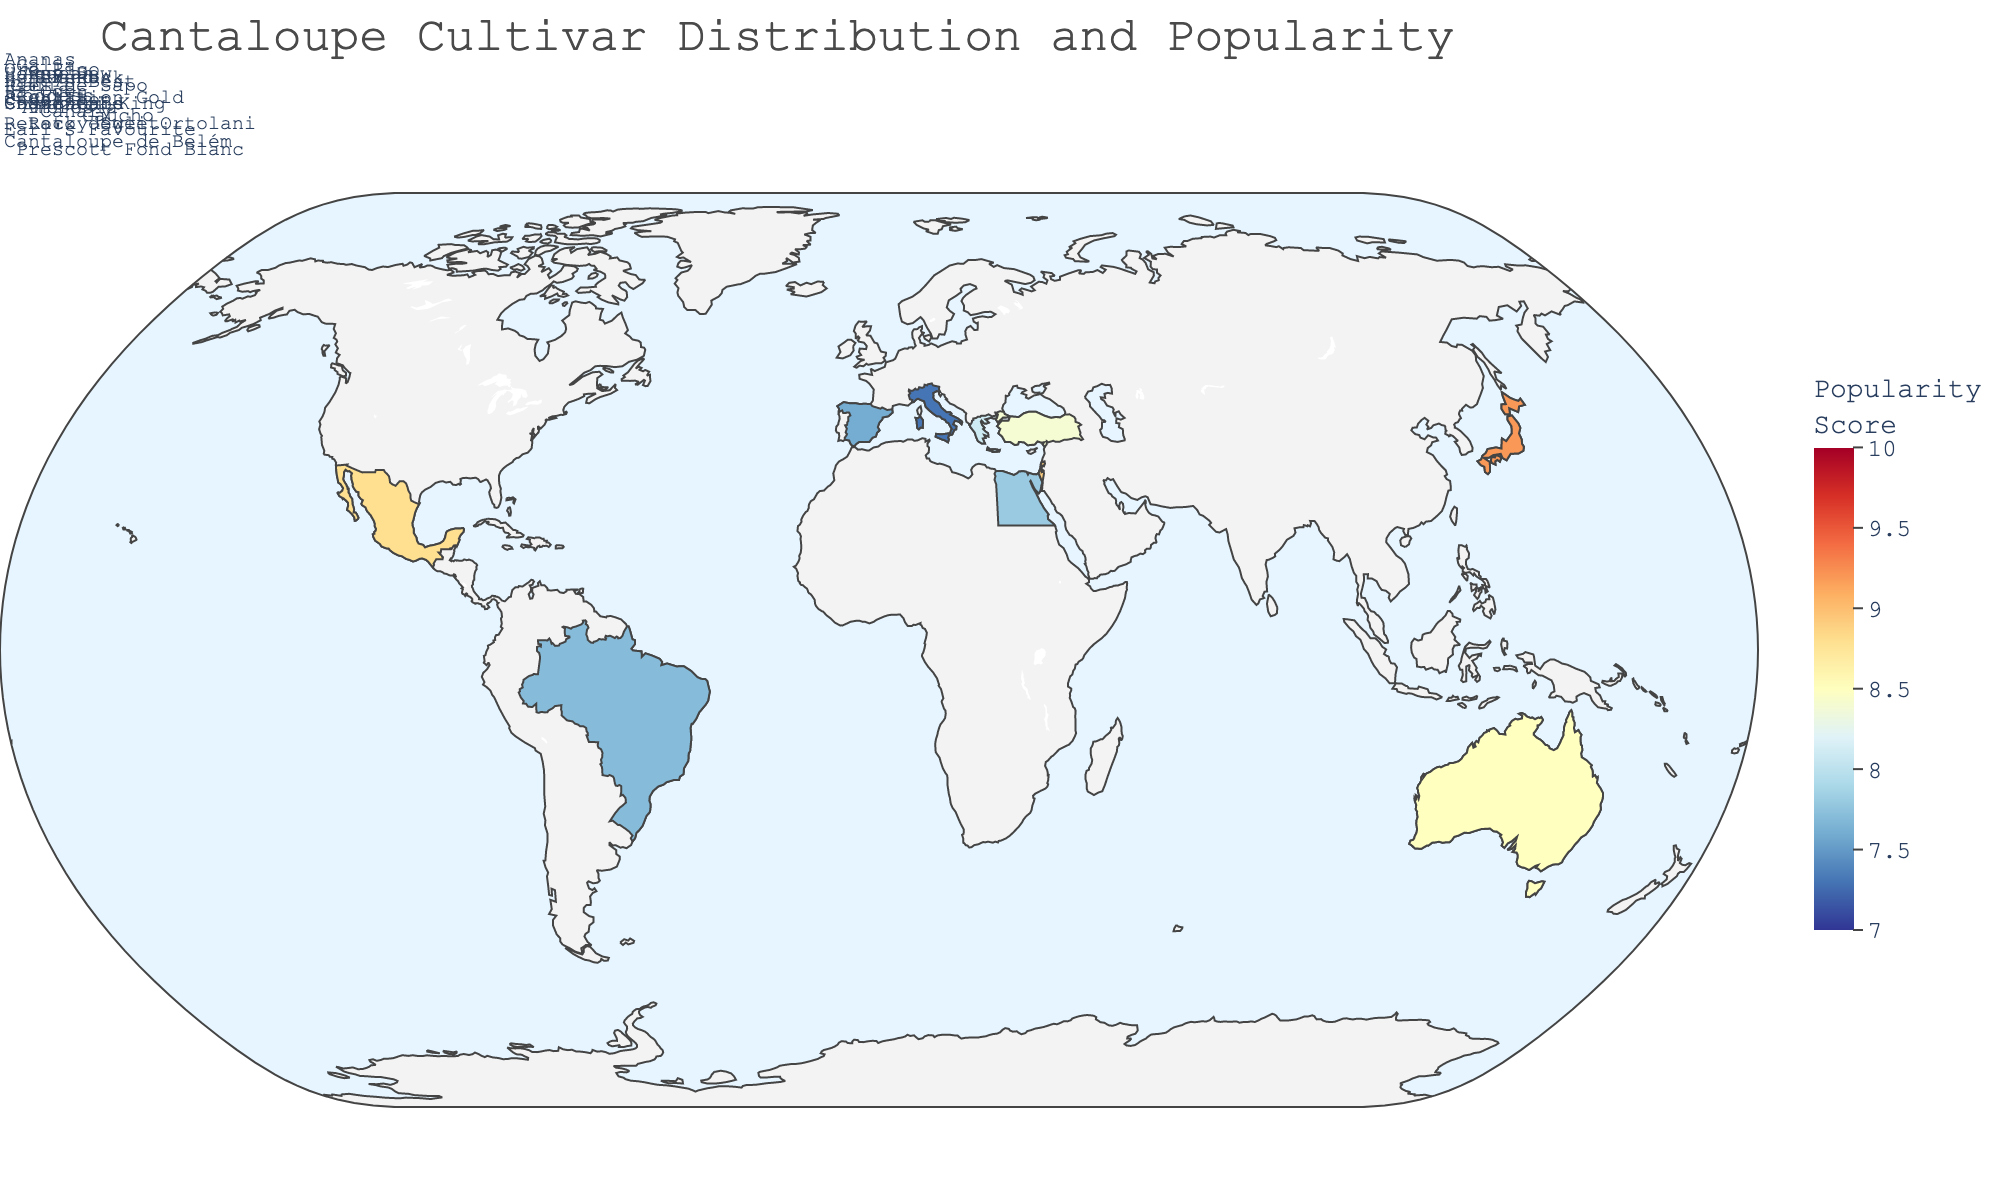how many regions are represented on the map? Looking at the geographic plot, count the number of distinct regions listed. There are 14 regions depicted.
Answer: 14 Which region has the highest Popularity Score? Identify the region with the highest numerical Popularity Score on the map. California has the highest Popularity Score of 9.5.
Answer: California What is the range of the Popularity Scores among all regions? Find the minimum and maximum Popularity Scores and calculate the difference between them. The minimum score is 7.3 (Italy) and the maximum is 9.5 (California), so the range is 9.5 - 7.3 = 2.2.
Answer: 2.2 Which regions have a Secondary Cultivar of 'Galia'? Look at the annotations or hover-over data on the map to find regions with 'Galia' listed as the secondary cultivar. Regions with 'Galia' as the secondary cultivar are Mexico and Turkey.
Answer: Mexico, Turkey What are the Dominant and Secondary Cultivars in Israel? Locate Israel on the map and check the annotations or hover-over data to find the listed cultivars. The Dominant Cultivar is 'Galia' and the Secondary Cultivar is 'Ha'Ogen'.
Answer: Galia, Ha'Ogen How does the Popularity Score of Japan compare to that of Israel? Compare the Popularity Scores next to the regions Japan and Israel. Japan's Popularity Score is 9.2, which is higher than Israel's score of 8.9.
Answer: Japan's score is higher Which region has the least Popularity Score and what are its cultivars? Identify the region with the lowest numerical score and note its Dominant and Secondary Cultivars. Italy has the lowest Popularity Score of 7.3, and its dominant cultivar is 'Retato degli Ortolani' and secondary cultivar is 'Prescott Fond Blanc'.
Answer: Italy, Retato degli Ortolani, Prescott Fond Blanc What is the average Popularity Score of all regions in the plot? Add up all the Popularity Scores and divide by the number of regions (14). (9.5 + 8.7 + 7.9 + 8.2 + 8.8 + 7.6 + 7.3 + 8.1 + 8.4 + 7.8 + 8.9 + 9.2 + 8.5 + 7.7) / 14 = 8.25
Answer: 8.25 